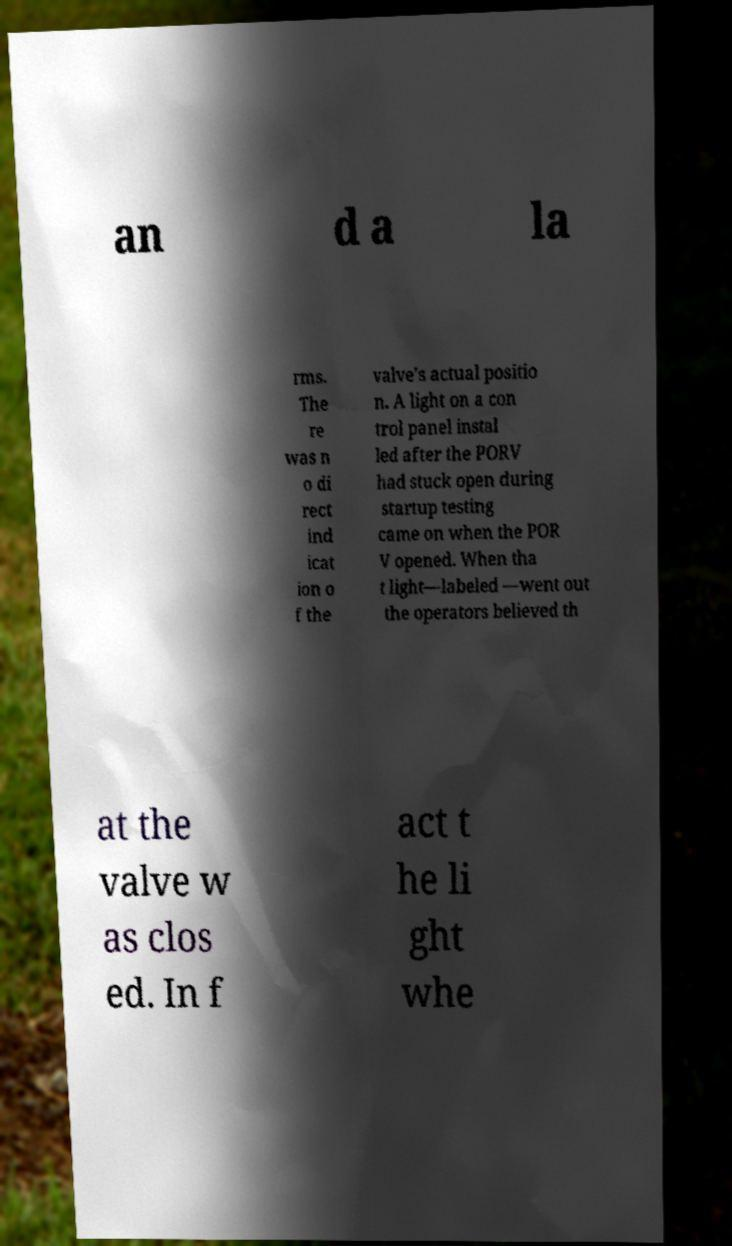Can you read and provide the text displayed in the image?This photo seems to have some interesting text. Can you extract and type it out for me? an d a la rms. The re was n o di rect ind icat ion o f the valve’s actual positio n. A light on a con trol panel instal led after the PORV had stuck open during startup testing came on when the POR V opened. When tha t light—labeled —went out the operators believed th at the valve w as clos ed. In f act t he li ght whe 